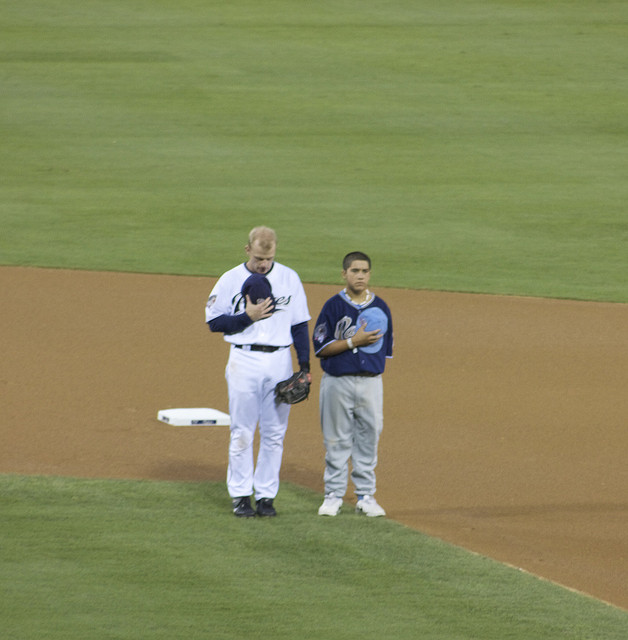Identify the text contained in this image. cs 